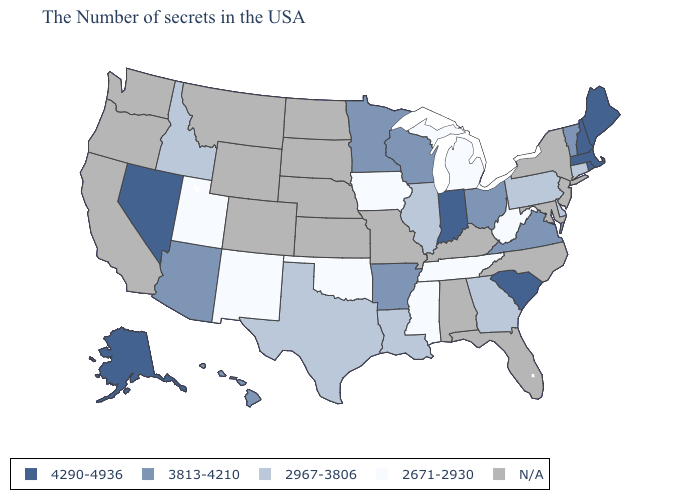What is the value of Vermont?
Concise answer only. 3813-4210. Does Alaska have the highest value in the USA?
Quick response, please. Yes. Does New Hampshire have the highest value in the USA?
Keep it brief. Yes. Name the states that have a value in the range 4290-4936?
Answer briefly. Maine, Massachusetts, Rhode Island, New Hampshire, South Carolina, Indiana, Nevada, Alaska. Name the states that have a value in the range 3813-4210?
Answer briefly. Vermont, Virginia, Ohio, Wisconsin, Arkansas, Minnesota, Arizona, Hawaii. What is the lowest value in the Northeast?
Answer briefly. 2967-3806. Is the legend a continuous bar?
Answer briefly. No. What is the value of Pennsylvania?
Write a very short answer. 2967-3806. Is the legend a continuous bar?
Concise answer only. No. Name the states that have a value in the range 3813-4210?
Keep it brief. Vermont, Virginia, Ohio, Wisconsin, Arkansas, Minnesota, Arizona, Hawaii. What is the value of Florida?
Write a very short answer. N/A. How many symbols are there in the legend?
Write a very short answer. 5. What is the highest value in the Northeast ?
Be succinct. 4290-4936. 